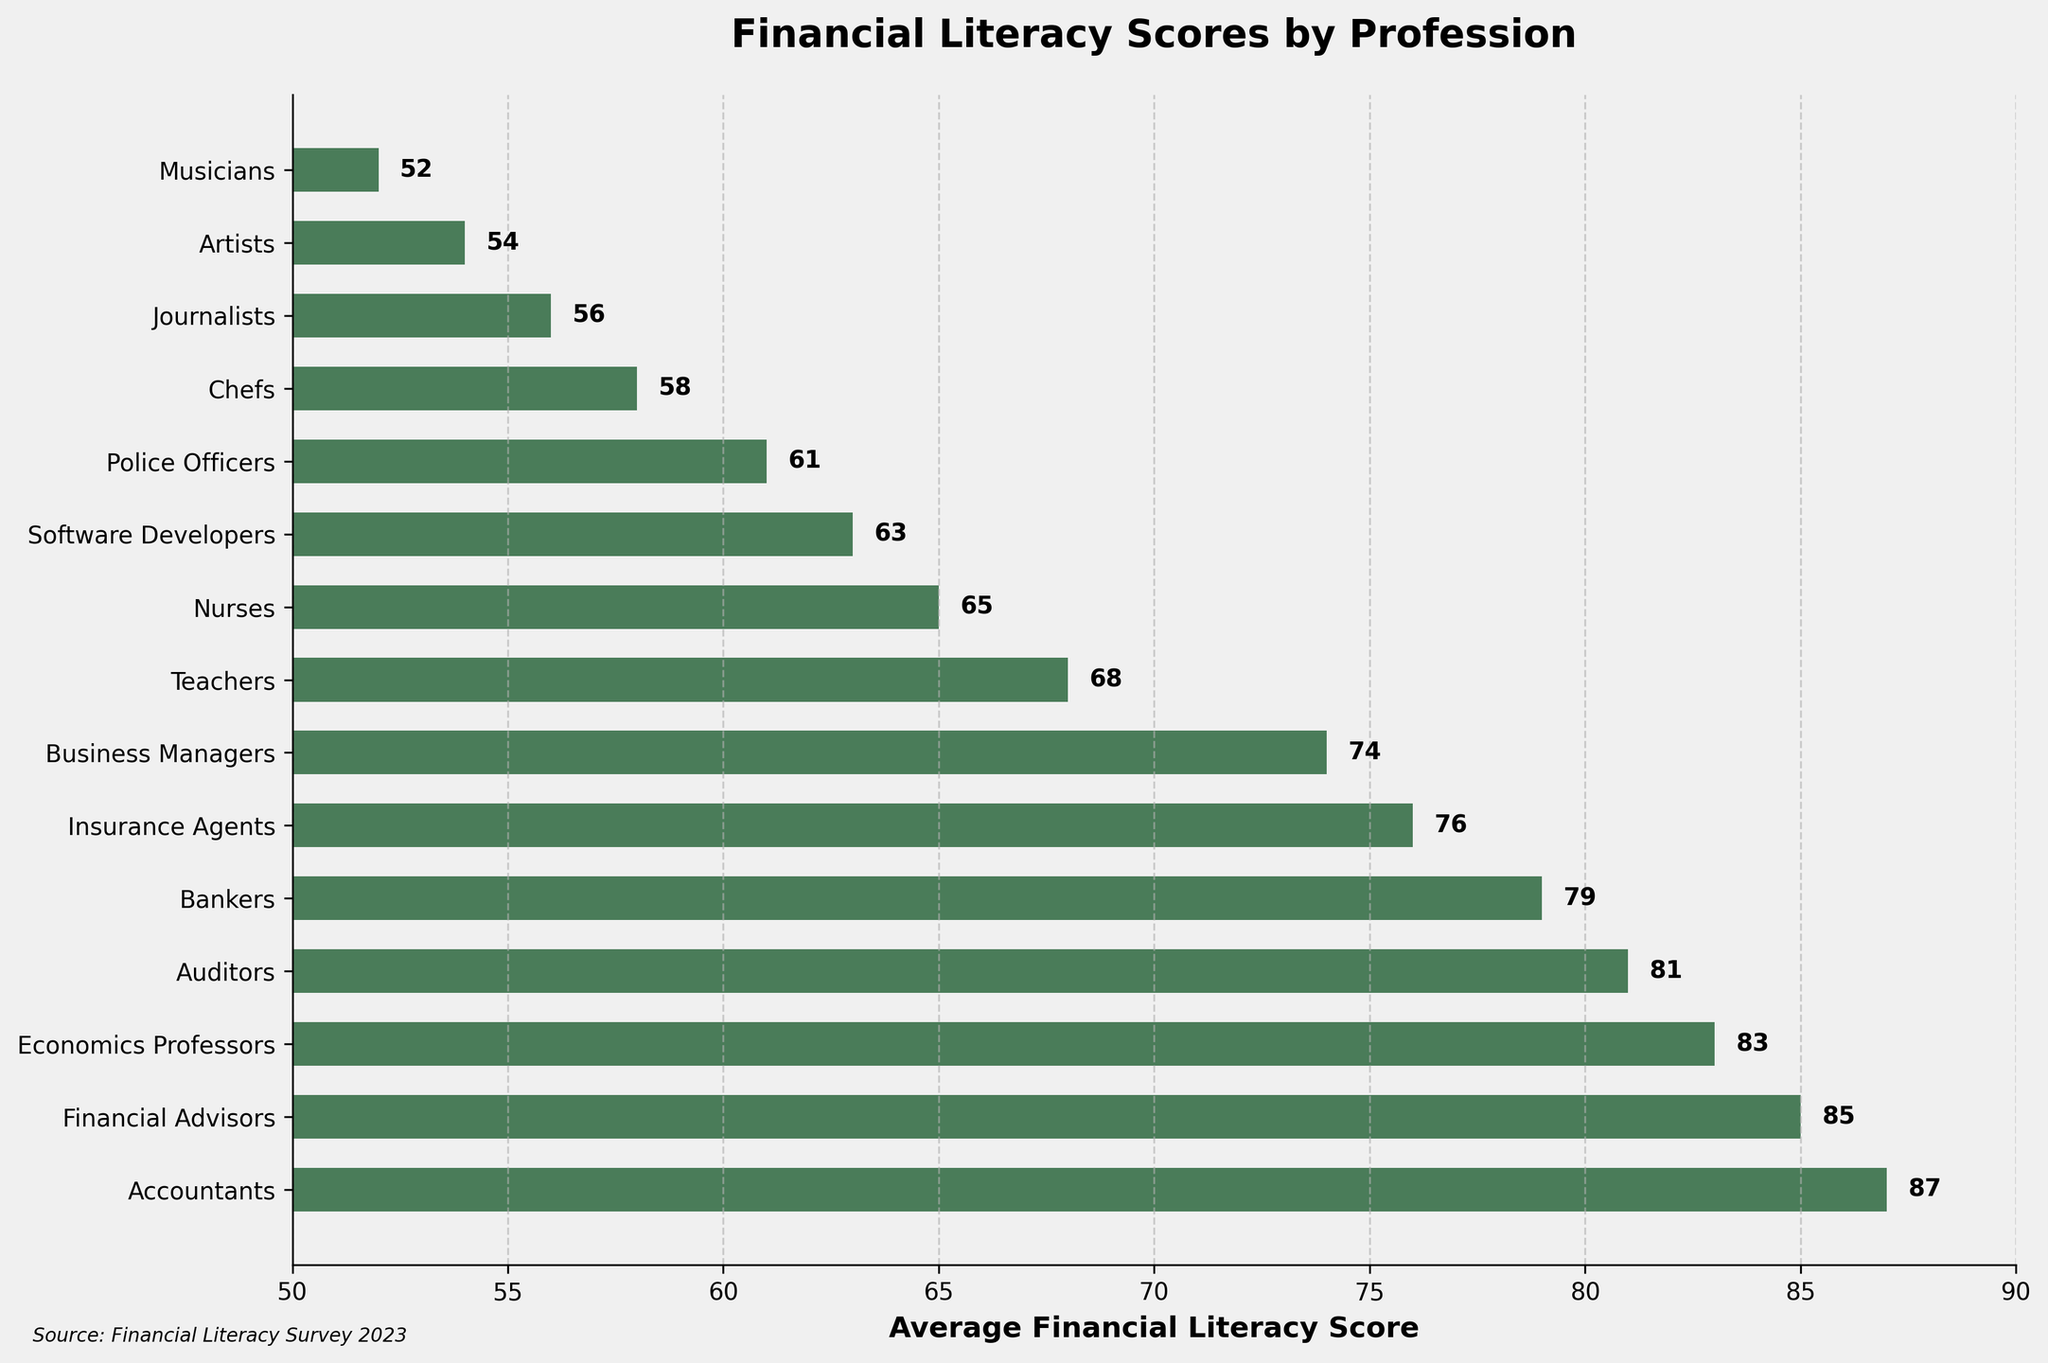Which profession has the highest average financial literacy score? The figure shows a bar chart where each bar represents the average financial literacy score of various professions. The profession with the highest bar has the highest score.
Answer: Accountants Which profession has the lowest average financial literacy score? By looking at the bar representing the lowest value on the x-axis, we can identify the profession with the lowest score.
Answer: Musicians What is the difference between the scores of Financial Advisors and Bankers? Find the lengths of the bars for both Financial Advisors (85) and Bankers (79). The difference is 85 - 79.
Answer: 6 How many professions have an average financial literacy score of 80 or above? Count the bars that have a length of 80 or more. These bars represent scores equal to or greater than 80.
Answer: 4 Compare the average financial literacy scores of Nurses and Police Officers. Which one is higher, and by how much? Examine the lengths of the bars for Nurses (65) and Police Officers (61). Nurses have a higher score than Police Officers. To find the difference: 65 - 61.
Answer: Nurses; 4 What is the average of the scores for Teachers, Nurses, and Software Developers? Identify the scores of Teachers (68), Nurses (65), and Software Developers (63). Sum these scores and divide by the number of professions: (68 + 65 + 63) / 3.
Answer: 65.33 Which profession ranks just below Auditors in average financial literacy score? Identify the bar immediately below the one representing Auditors (81). The profession represented by the next bar below has slightly lower but close to 81 score.
Answer: Bankers What is the range of financial literacy scores among Artists, Chefs, and Journalists? Determine the highest and lowest scores among these three professions: Artists (54), Chefs (58), and Journalists (56). The range is the difference between the highest and lowest scores: 58 - 54.
Answer: 4 Is the average financial literacy score for Business Managers higher or lower compared to Insurance Agents, and by what value? Check the lengths of the bars for Business Managers (74) and Insurance Agents (76). Business Managers have a lower score. The difference is 76 - 74.
Answer: Lower; 2 Which is the first profession below the median score? The median for 15 professions is the score of the 8th profession (as 15/2 = 7.5, rounded up to 8th). Identifying from ranking, the middle score above and below this line gives us the first below median.
Answer: Teachers 